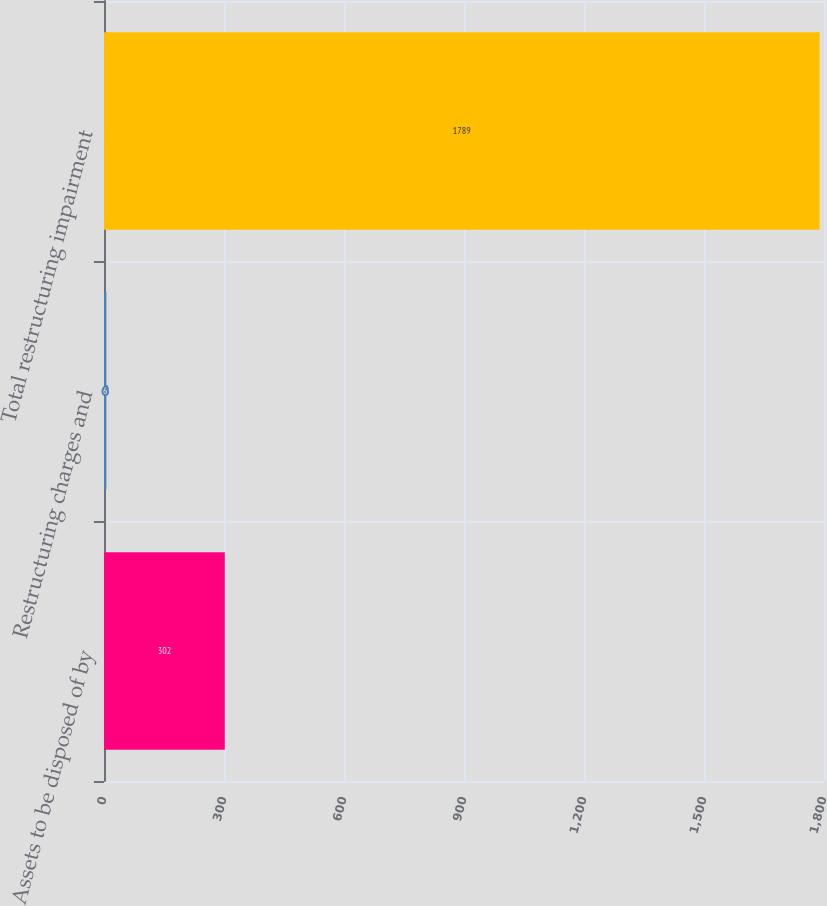Convert chart to OTSL. <chart><loc_0><loc_0><loc_500><loc_500><bar_chart><fcel>Assets to be disposed of by<fcel>Restructuring charges and<fcel>Total restructuring impairment<nl><fcel>302<fcel>6<fcel>1789<nl></chart> 